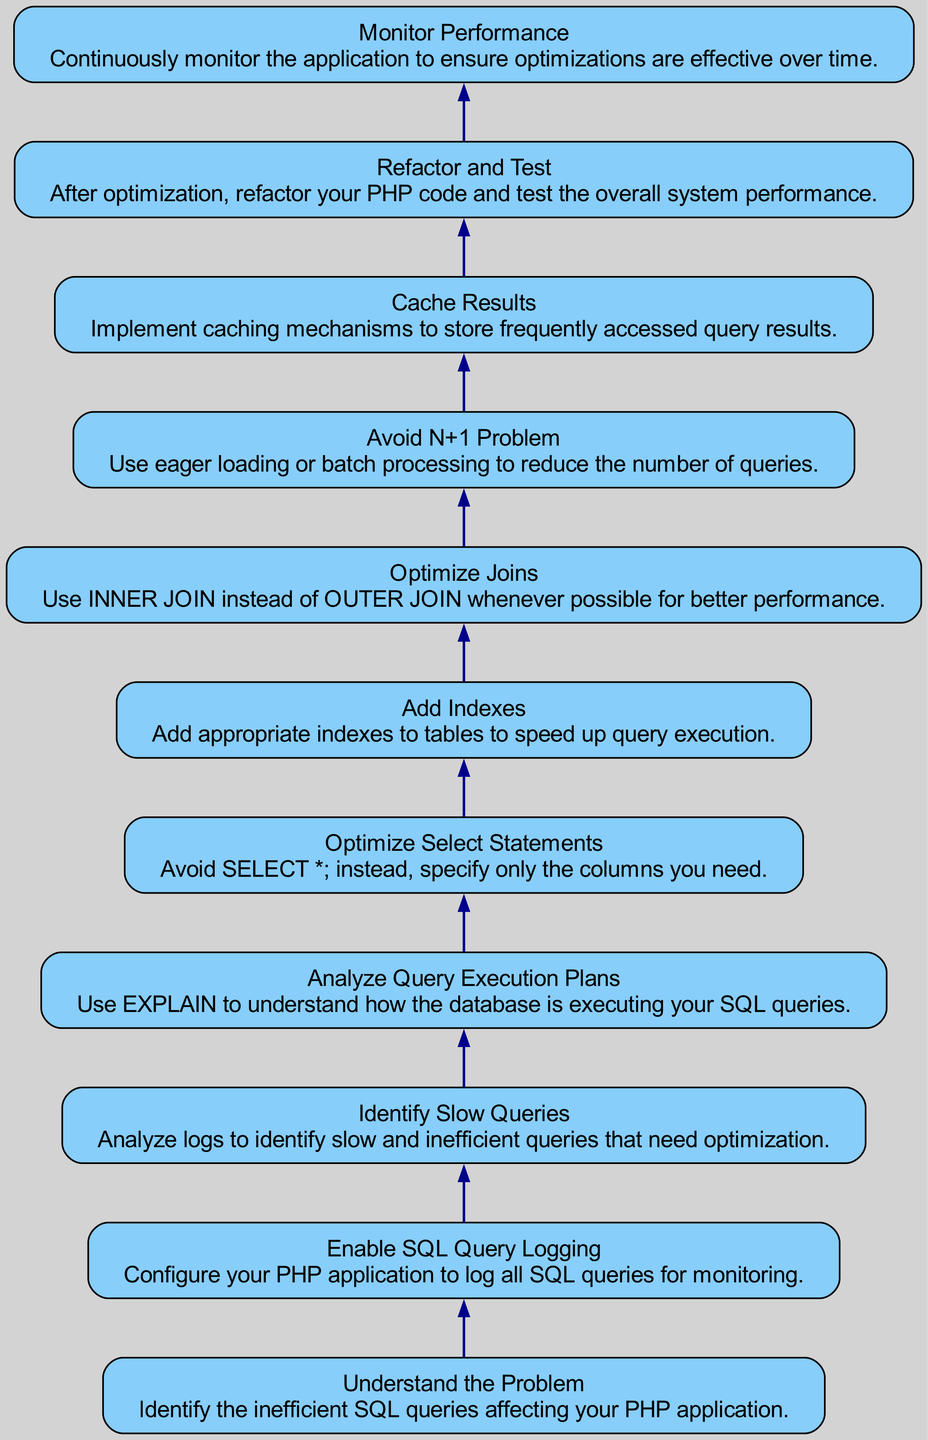What is the first step in the optimization process? The first step is to "Understand the Problem," which involves identifying the inefficient SQL queries affecting your PHP application.
Answer: Understand the Problem How many nodes are there in the flow chart? By counting the individual steps outlined in the diagram, we can see there are eleven distinct nodes representing different stages of the optimization process.
Answer: 11 What action is taken after "Enable SQL Query Logging"? Following "Enable SQL Query Logging," the next action is "Identify Slow Queries," which entails analyzing the logs to find slow and inefficient queries that need optimization.
Answer: Identify Slow Queries What should be done to optimize SELECT statements? To optimize SELECT statements, you should "Optimize Select Statements" by avoiding the use of SELECT * and instead specifying only the columns you need.
Answer: Optimize Select Statements What is indicated by the last step in the flow chart? The last step is "Monitor Performance," which emphasizes the need to continuously monitor the application to ensure that the optimizations are effective over time.
Answer: Monitor Performance What is the focus of the "Analyze Query Execution Plans" step? The focus of this step is to use the EXPLAIN command to understand how the database executes your SQL queries, providing insights for optimization.
Answer: EXPLAIN What does "Avoid N+1 Problem" suggest for reducing queries? This step suggests using eager loading or batch processing to reduce the number of queries executed, thus optimizing performance.
Answer: Eager loading or batch processing Which step involves adding indexes to tables? The step that involves adding indexes is labeled "Add Indexes," which aims to speed up query execution by implementing appropriate indexes.
Answer: Add Indexes What is the relationship between "Optimize Joins" and performance? The relationship is that optimizing joins by using INNER JOIN instead of OUTER JOIN whenever possible generally results in better query performance.
Answer: INNER JOIN 